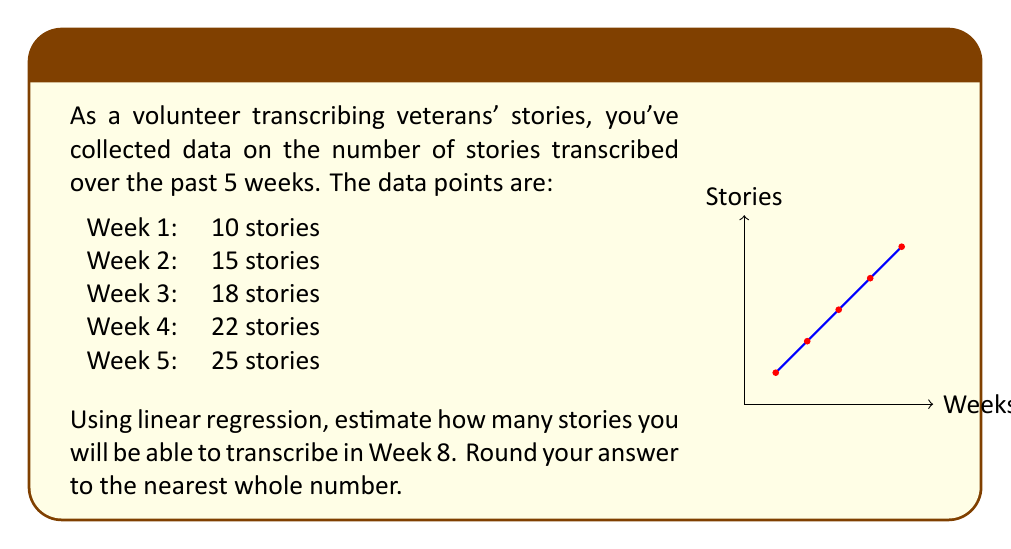Solve this math problem. To solve this problem using linear regression, we'll follow these steps:

1) First, let's calculate the means of x (weeks) and y (stories):
   $\bar{x} = \frac{1+2+3+4+5}{5} = 3$
   $\bar{y} = \frac{10+15+18+22+25}{5} = 18$

2) Now, we need to calculate the slope (m) of the regression line:
   $m = \frac{\sum(x_i - \bar{x})(y_i - \bar{y})}{\sum(x_i - \bar{x})^2}$

3) Let's calculate the numerator and denominator separately:
   Numerator: $(-2)(-8) + (-1)(-3) + (0)(0) + (1)(4) + (2)(7) = 16 + 3 + 0 + 4 + 14 = 37$
   Denominator: $(-2)^2 + (-1)^2 + (0)^2 + (1)^2 + (2)^2 = 4 + 1 + 0 + 1 + 4 = 10$

4) Now we can calculate the slope:
   $m = \frac{37}{10} = 3.7$

5) We can find the y-intercept (b) using the point-slope form:
   $18 = 3.7(3) + b$
   $b = 18 - 11.1 = 6.9$

6) Our regression line equation is:
   $y = 3.7x + 6.9$

7) To estimate the number of stories for Week 8, we plug in x = 8:
   $y = 3.7(8) + 6.9 = 29.6 + 6.9 = 36.5$

8) Rounding to the nearest whole number:
   $36.5 \approx 37$
Answer: 37 stories 